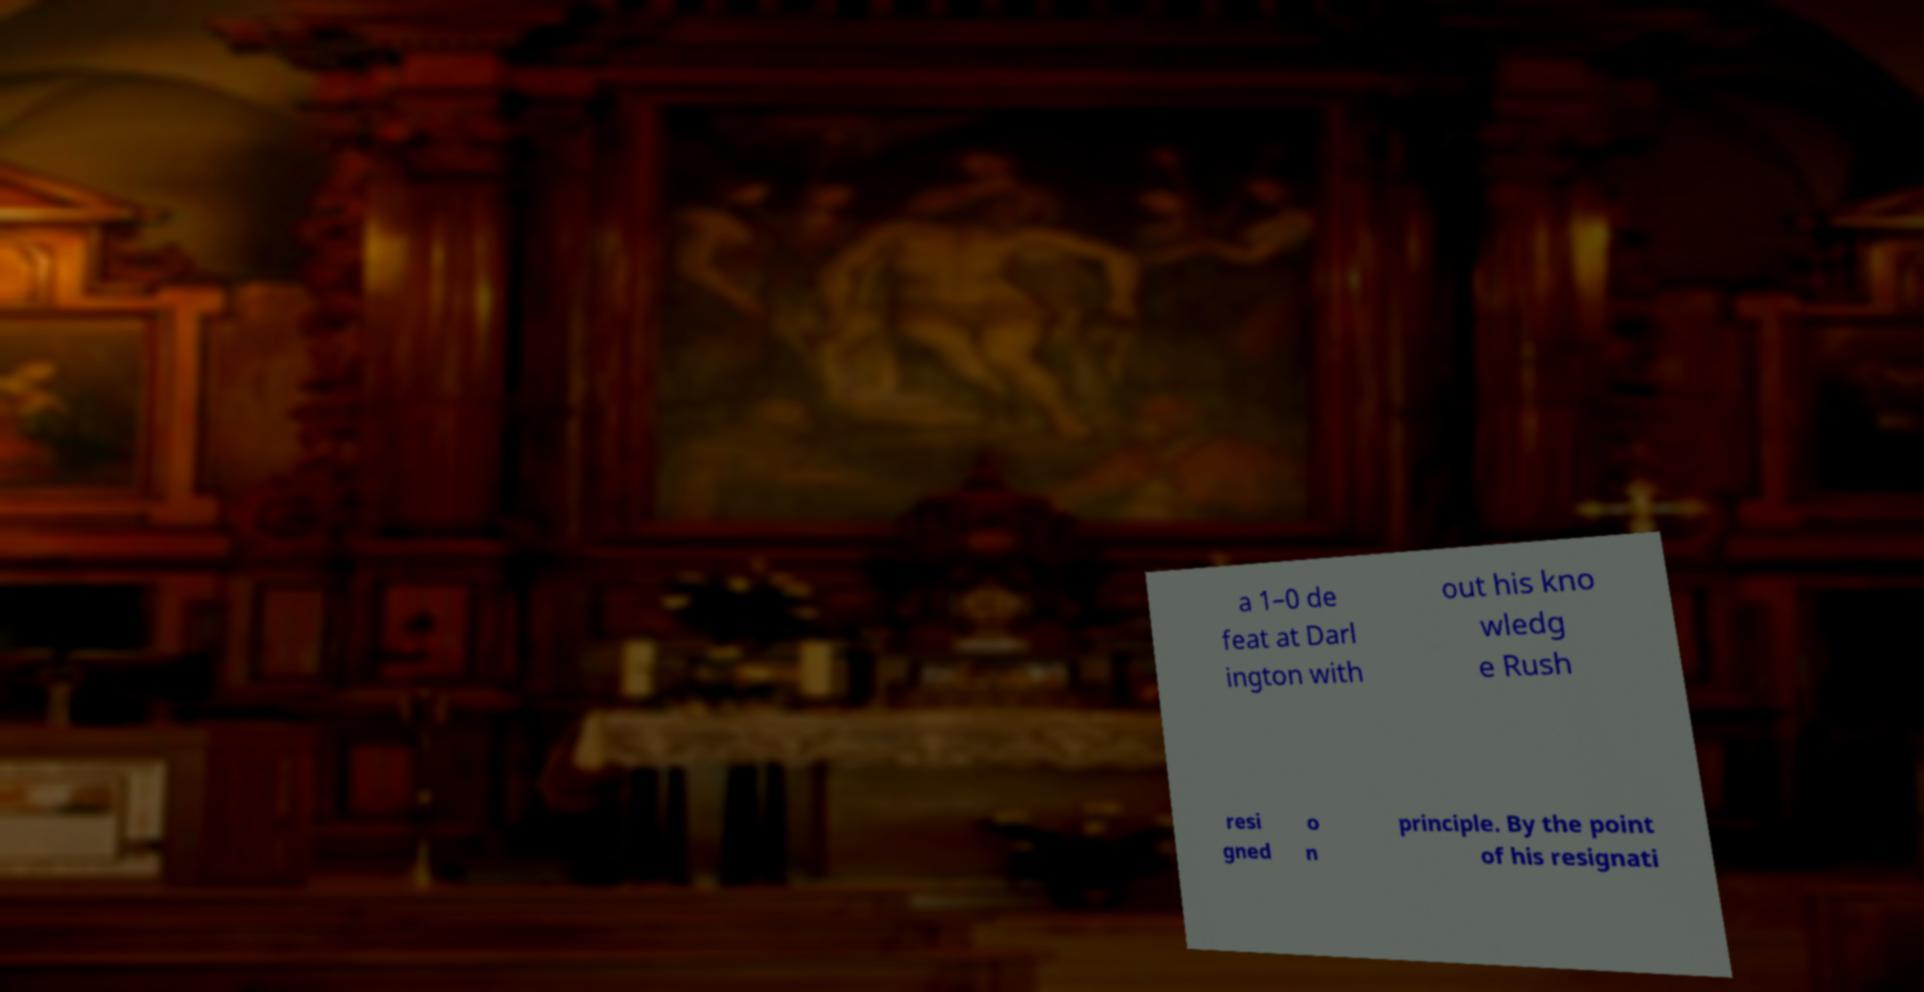For documentation purposes, I need the text within this image transcribed. Could you provide that? a 1–0 de feat at Darl ington with out his kno wledg e Rush resi gned o n principle. By the point of his resignati 